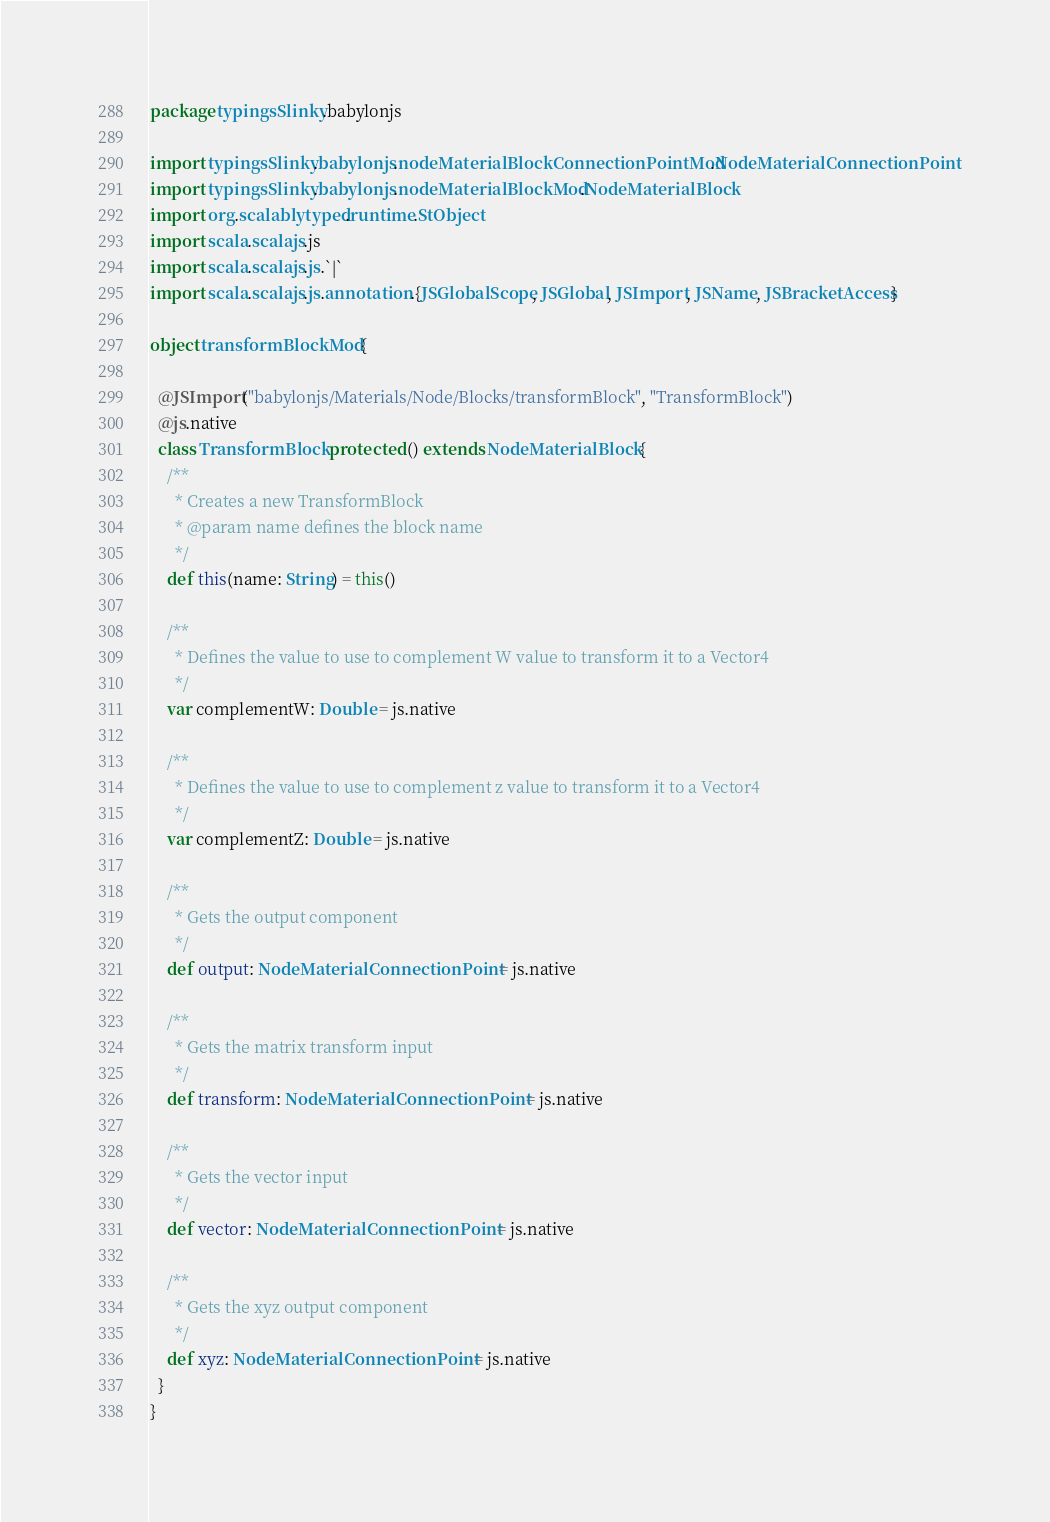<code> <loc_0><loc_0><loc_500><loc_500><_Scala_>package typingsSlinky.babylonjs

import typingsSlinky.babylonjs.nodeMaterialBlockConnectionPointMod.NodeMaterialConnectionPoint
import typingsSlinky.babylonjs.nodeMaterialBlockMod.NodeMaterialBlock
import org.scalablytyped.runtime.StObject
import scala.scalajs.js
import scala.scalajs.js.`|`
import scala.scalajs.js.annotation.{JSGlobalScope, JSGlobal, JSImport, JSName, JSBracketAccess}

object transformBlockMod {
  
  @JSImport("babylonjs/Materials/Node/Blocks/transformBlock", "TransformBlock")
  @js.native
  class TransformBlock protected () extends NodeMaterialBlock {
    /**
      * Creates a new TransformBlock
      * @param name defines the block name
      */
    def this(name: String) = this()
    
    /**
      * Defines the value to use to complement W value to transform it to a Vector4
      */
    var complementW: Double = js.native
    
    /**
      * Defines the value to use to complement z value to transform it to a Vector4
      */
    var complementZ: Double = js.native
    
    /**
      * Gets the output component
      */
    def output: NodeMaterialConnectionPoint = js.native
    
    /**
      * Gets the matrix transform input
      */
    def transform: NodeMaterialConnectionPoint = js.native
    
    /**
      * Gets the vector input
      */
    def vector: NodeMaterialConnectionPoint = js.native
    
    /**
      * Gets the xyz output component
      */
    def xyz: NodeMaterialConnectionPoint = js.native
  }
}
</code> 